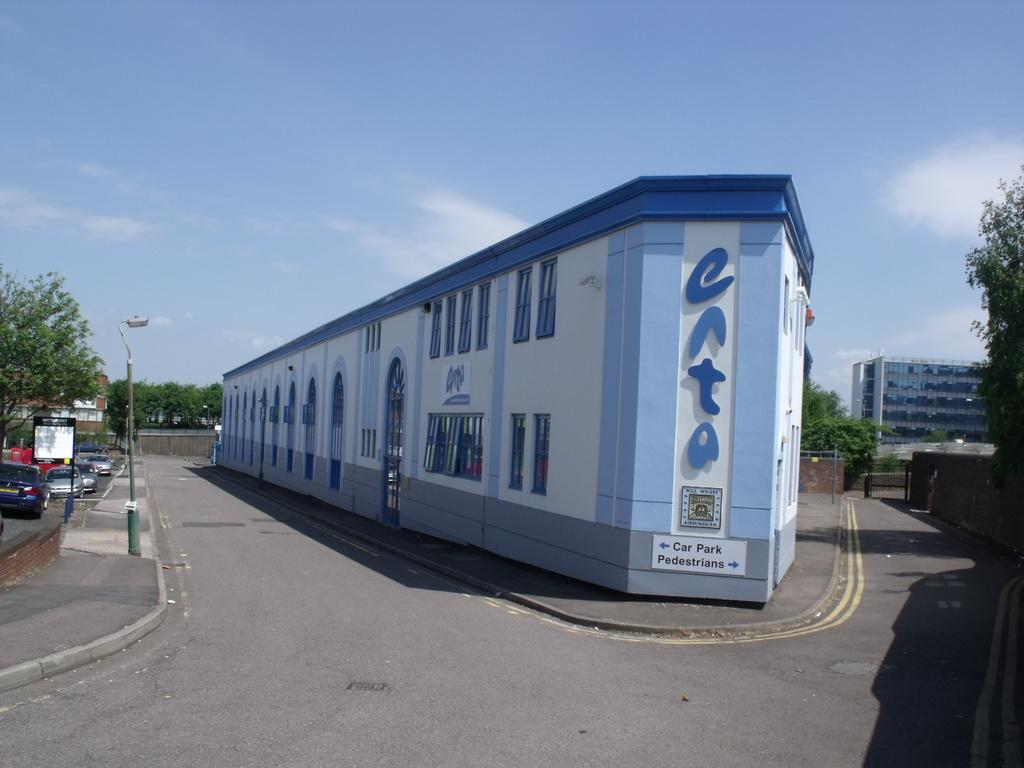<image>
Write a terse but informative summary of the picture. A building with car park and pedestrians on it 